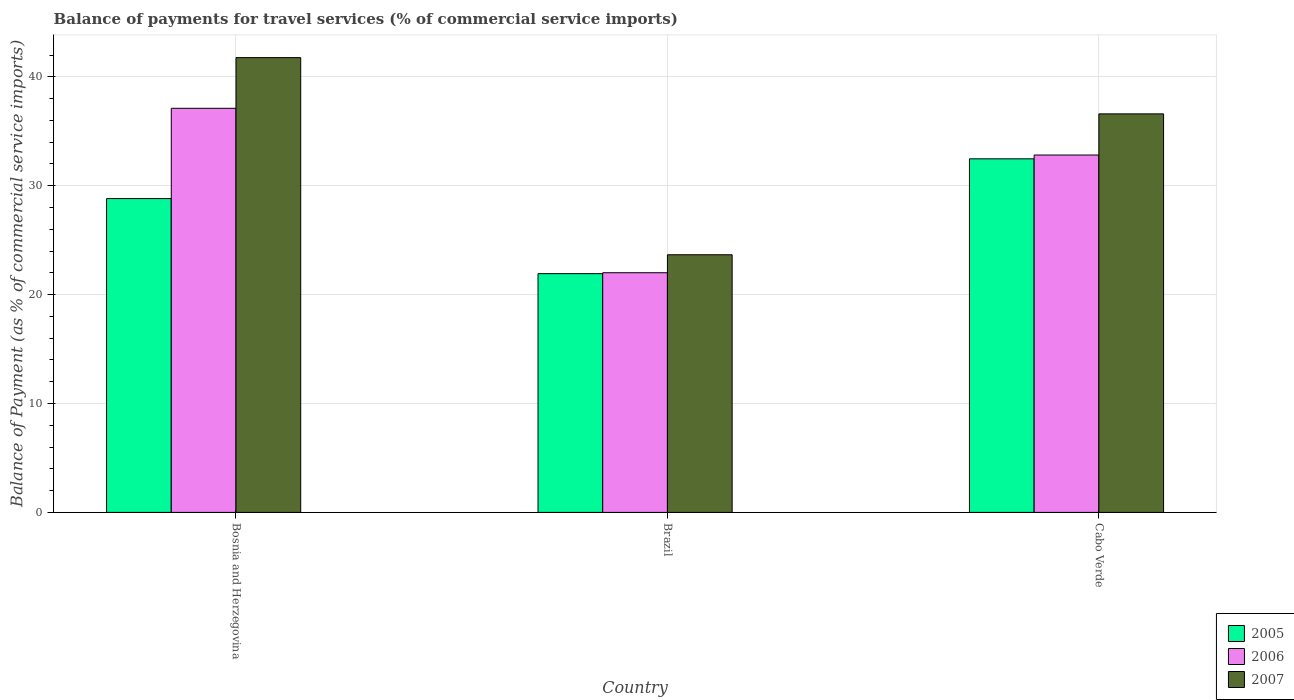Are the number of bars per tick equal to the number of legend labels?
Your answer should be very brief. Yes. Are the number of bars on each tick of the X-axis equal?
Your answer should be very brief. Yes. How many bars are there on the 1st tick from the left?
Provide a short and direct response. 3. What is the label of the 1st group of bars from the left?
Offer a terse response. Bosnia and Herzegovina. In how many cases, is the number of bars for a given country not equal to the number of legend labels?
Make the answer very short. 0. What is the balance of payments for travel services in 2005 in Cabo Verde?
Provide a succinct answer. 32.47. Across all countries, what is the maximum balance of payments for travel services in 2007?
Ensure brevity in your answer.  41.77. Across all countries, what is the minimum balance of payments for travel services in 2006?
Offer a very short reply. 22.01. In which country was the balance of payments for travel services in 2005 maximum?
Offer a terse response. Cabo Verde. What is the total balance of payments for travel services in 2007 in the graph?
Your answer should be very brief. 102.04. What is the difference between the balance of payments for travel services in 2005 in Brazil and that in Cabo Verde?
Keep it short and to the point. -10.55. What is the difference between the balance of payments for travel services in 2007 in Bosnia and Herzegovina and the balance of payments for travel services in 2005 in Cabo Verde?
Make the answer very short. 9.3. What is the average balance of payments for travel services in 2007 per country?
Your response must be concise. 34.01. What is the difference between the balance of payments for travel services of/in 2005 and balance of payments for travel services of/in 2006 in Bosnia and Herzegovina?
Your response must be concise. -8.29. In how many countries, is the balance of payments for travel services in 2005 greater than 28 %?
Make the answer very short. 2. What is the ratio of the balance of payments for travel services in 2005 in Bosnia and Herzegovina to that in Brazil?
Offer a terse response. 1.31. Is the difference between the balance of payments for travel services in 2005 in Brazil and Cabo Verde greater than the difference between the balance of payments for travel services in 2006 in Brazil and Cabo Verde?
Make the answer very short. Yes. What is the difference between the highest and the second highest balance of payments for travel services in 2007?
Provide a succinct answer. 5.17. What is the difference between the highest and the lowest balance of payments for travel services in 2007?
Keep it short and to the point. 18.11. In how many countries, is the balance of payments for travel services in 2005 greater than the average balance of payments for travel services in 2005 taken over all countries?
Provide a short and direct response. 2. Is the sum of the balance of payments for travel services in 2005 in Brazil and Cabo Verde greater than the maximum balance of payments for travel services in 2007 across all countries?
Provide a succinct answer. Yes. Is it the case that in every country, the sum of the balance of payments for travel services in 2007 and balance of payments for travel services in 2006 is greater than the balance of payments for travel services in 2005?
Give a very brief answer. Yes. Are all the bars in the graph horizontal?
Provide a succinct answer. No. How many countries are there in the graph?
Your response must be concise. 3. Does the graph contain any zero values?
Your answer should be very brief. No. Does the graph contain grids?
Provide a short and direct response. Yes. How many legend labels are there?
Offer a terse response. 3. What is the title of the graph?
Offer a very short reply. Balance of payments for travel services (% of commercial service imports). What is the label or title of the X-axis?
Provide a succinct answer. Country. What is the label or title of the Y-axis?
Provide a succinct answer. Balance of Payment (as % of commercial service imports). What is the Balance of Payment (as % of commercial service imports) of 2005 in Bosnia and Herzegovina?
Your answer should be very brief. 28.82. What is the Balance of Payment (as % of commercial service imports) in 2006 in Bosnia and Herzegovina?
Make the answer very short. 37.12. What is the Balance of Payment (as % of commercial service imports) in 2007 in Bosnia and Herzegovina?
Keep it short and to the point. 41.77. What is the Balance of Payment (as % of commercial service imports) of 2005 in Brazil?
Your answer should be very brief. 21.93. What is the Balance of Payment (as % of commercial service imports) of 2006 in Brazil?
Offer a very short reply. 22.01. What is the Balance of Payment (as % of commercial service imports) of 2007 in Brazil?
Your response must be concise. 23.66. What is the Balance of Payment (as % of commercial service imports) in 2005 in Cabo Verde?
Offer a very short reply. 32.47. What is the Balance of Payment (as % of commercial service imports) of 2006 in Cabo Verde?
Offer a terse response. 32.82. What is the Balance of Payment (as % of commercial service imports) in 2007 in Cabo Verde?
Your response must be concise. 36.6. Across all countries, what is the maximum Balance of Payment (as % of commercial service imports) of 2005?
Make the answer very short. 32.47. Across all countries, what is the maximum Balance of Payment (as % of commercial service imports) in 2006?
Provide a short and direct response. 37.12. Across all countries, what is the maximum Balance of Payment (as % of commercial service imports) in 2007?
Make the answer very short. 41.77. Across all countries, what is the minimum Balance of Payment (as % of commercial service imports) of 2005?
Provide a succinct answer. 21.93. Across all countries, what is the minimum Balance of Payment (as % of commercial service imports) of 2006?
Offer a terse response. 22.01. Across all countries, what is the minimum Balance of Payment (as % of commercial service imports) of 2007?
Offer a very short reply. 23.66. What is the total Balance of Payment (as % of commercial service imports) of 2005 in the graph?
Your answer should be compact. 83.23. What is the total Balance of Payment (as % of commercial service imports) of 2006 in the graph?
Provide a succinct answer. 91.95. What is the total Balance of Payment (as % of commercial service imports) in 2007 in the graph?
Give a very brief answer. 102.04. What is the difference between the Balance of Payment (as % of commercial service imports) of 2005 in Bosnia and Herzegovina and that in Brazil?
Your response must be concise. 6.9. What is the difference between the Balance of Payment (as % of commercial service imports) of 2006 in Bosnia and Herzegovina and that in Brazil?
Provide a succinct answer. 15.1. What is the difference between the Balance of Payment (as % of commercial service imports) in 2007 in Bosnia and Herzegovina and that in Brazil?
Your response must be concise. 18.11. What is the difference between the Balance of Payment (as % of commercial service imports) of 2005 in Bosnia and Herzegovina and that in Cabo Verde?
Keep it short and to the point. -3.65. What is the difference between the Balance of Payment (as % of commercial service imports) of 2006 in Bosnia and Herzegovina and that in Cabo Verde?
Your response must be concise. 4.29. What is the difference between the Balance of Payment (as % of commercial service imports) of 2007 in Bosnia and Herzegovina and that in Cabo Verde?
Provide a short and direct response. 5.17. What is the difference between the Balance of Payment (as % of commercial service imports) of 2005 in Brazil and that in Cabo Verde?
Offer a terse response. -10.55. What is the difference between the Balance of Payment (as % of commercial service imports) of 2006 in Brazil and that in Cabo Verde?
Your answer should be very brief. -10.81. What is the difference between the Balance of Payment (as % of commercial service imports) in 2007 in Brazil and that in Cabo Verde?
Make the answer very short. -12.94. What is the difference between the Balance of Payment (as % of commercial service imports) in 2005 in Bosnia and Herzegovina and the Balance of Payment (as % of commercial service imports) in 2006 in Brazil?
Offer a very short reply. 6.81. What is the difference between the Balance of Payment (as % of commercial service imports) in 2005 in Bosnia and Herzegovina and the Balance of Payment (as % of commercial service imports) in 2007 in Brazil?
Ensure brevity in your answer.  5.16. What is the difference between the Balance of Payment (as % of commercial service imports) of 2006 in Bosnia and Herzegovina and the Balance of Payment (as % of commercial service imports) of 2007 in Brazil?
Give a very brief answer. 13.45. What is the difference between the Balance of Payment (as % of commercial service imports) in 2005 in Bosnia and Herzegovina and the Balance of Payment (as % of commercial service imports) in 2006 in Cabo Verde?
Your response must be concise. -4. What is the difference between the Balance of Payment (as % of commercial service imports) in 2005 in Bosnia and Herzegovina and the Balance of Payment (as % of commercial service imports) in 2007 in Cabo Verde?
Your response must be concise. -7.78. What is the difference between the Balance of Payment (as % of commercial service imports) in 2006 in Bosnia and Herzegovina and the Balance of Payment (as % of commercial service imports) in 2007 in Cabo Verde?
Ensure brevity in your answer.  0.51. What is the difference between the Balance of Payment (as % of commercial service imports) of 2005 in Brazil and the Balance of Payment (as % of commercial service imports) of 2006 in Cabo Verde?
Your response must be concise. -10.89. What is the difference between the Balance of Payment (as % of commercial service imports) of 2005 in Brazil and the Balance of Payment (as % of commercial service imports) of 2007 in Cabo Verde?
Provide a short and direct response. -14.68. What is the difference between the Balance of Payment (as % of commercial service imports) in 2006 in Brazil and the Balance of Payment (as % of commercial service imports) in 2007 in Cabo Verde?
Offer a very short reply. -14.59. What is the average Balance of Payment (as % of commercial service imports) in 2005 per country?
Ensure brevity in your answer.  27.74. What is the average Balance of Payment (as % of commercial service imports) in 2006 per country?
Your answer should be compact. 30.65. What is the average Balance of Payment (as % of commercial service imports) in 2007 per country?
Ensure brevity in your answer.  34.01. What is the difference between the Balance of Payment (as % of commercial service imports) of 2005 and Balance of Payment (as % of commercial service imports) of 2006 in Bosnia and Herzegovina?
Your response must be concise. -8.29. What is the difference between the Balance of Payment (as % of commercial service imports) of 2005 and Balance of Payment (as % of commercial service imports) of 2007 in Bosnia and Herzegovina?
Provide a succinct answer. -12.95. What is the difference between the Balance of Payment (as % of commercial service imports) of 2006 and Balance of Payment (as % of commercial service imports) of 2007 in Bosnia and Herzegovina?
Offer a very short reply. -4.66. What is the difference between the Balance of Payment (as % of commercial service imports) in 2005 and Balance of Payment (as % of commercial service imports) in 2006 in Brazil?
Make the answer very short. -0.09. What is the difference between the Balance of Payment (as % of commercial service imports) in 2005 and Balance of Payment (as % of commercial service imports) in 2007 in Brazil?
Ensure brevity in your answer.  -1.74. What is the difference between the Balance of Payment (as % of commercial service imports) in 2006 and Balance of Payment (as % of commercial service imports) in 2007 in Brazil?
Your response must be concise. -1.65. What is the difference between the Balance of Payment (as % of commercial service imports) in 2005 and Balance of Payment (as % of commercial service imports) in 2006 in Cabo Verde?
Your response must be concise. -0.35. What is the difference between the Balance of Payment (as % of commercial service imports) in 2005 and Balance of Payment (as % of commercial service imports) in 2007 in Cabo Verde?
Ensure brevity in your answer.  -4.13. What is the difference between the Balance of Payment (as % of commercial service imports) in 2006 and Balance of Payment (as % of commercial service imports) in 2007 in Cabo Verde?
Make the answer very short. -3.78. What is the ratio of the Balance of Payment (as % of commercial service imports) in 2005 in Bosnia and Herzegovina to that in Brazil?
Your response must be concise. 1.31. What is the ratio of the Balance of Payment (as % of commercial service imports) of 2006 in Bosnia and Herzegovina to that in Brazil?
Provide a short and direct response. 1.69. What is the ratio of the Balance of Payment (as % of commercial service imports) in 2007 in Bosnia and Herzegovina to that in Brazil?
Provide a succinct answer. 1.77. What is the ratio of the Balance of Payment (as % of commercial service imports) of 2005 in Bosnia and Herzegovina to that in Cabo Verde?
Your answer should be very brief. 0.89. What is the ratio of the Balance of Payment (as % of commercial service imports) in 2006 in Bosnia and Herzegovina to that in Cabo Verde?
Ensure brevity in your answer.  1.13. What is the ratio of the Balance of Payment (as % of commercial service imports) in 2007 in Bosnia and Herzegovina to that in Cabo Verde?
Give a very brief answer. 1.14. What is the ratio of the Balance of Payment (as % of commercial service imports) in 2005 in Brazil to that in Cabo Verde?
Your answer should be very brief. 0.68. What is the ratio of the Balance of Payment (as % of commercial service imports) in 2006 in Brazil to that in Cabo Verde?
Offer a terse response. 0.67. What is the ratio of the Balance of Payment (as % of commercial service imports) of 2007 in Brazil to that in Cabo Verde?
Give a very brief answer. 0.65. What is the difference between the highest and the second highest Balance of Payment (as % of commercial service imports) of 2005?
Provide a short and direct response. 3.65. What is the difference between the highest and the second highest Balance of Payment (as % of commercial service imports) of 2006?
Your response must be concise. 4.29. What is the difference between the highest and the second highest Balance of Payment (as % of commercial service imports) of 2007?
Your response must be concise. 5.17. What is the difference between the highest and the lowest Balance of Payment (as % of commercial service imports) of 2005?
Your response must be concise. 10.55. What is the difference between the highest and the lowest Balance of Payment (as % of commercial service imports) of 2006?
Offer a very short reply. 15.1. What is the difference between the highest and the lowest Balance of Payment (as % of commercial service imports) of 2007?
Make the answer very short. 18.11. 